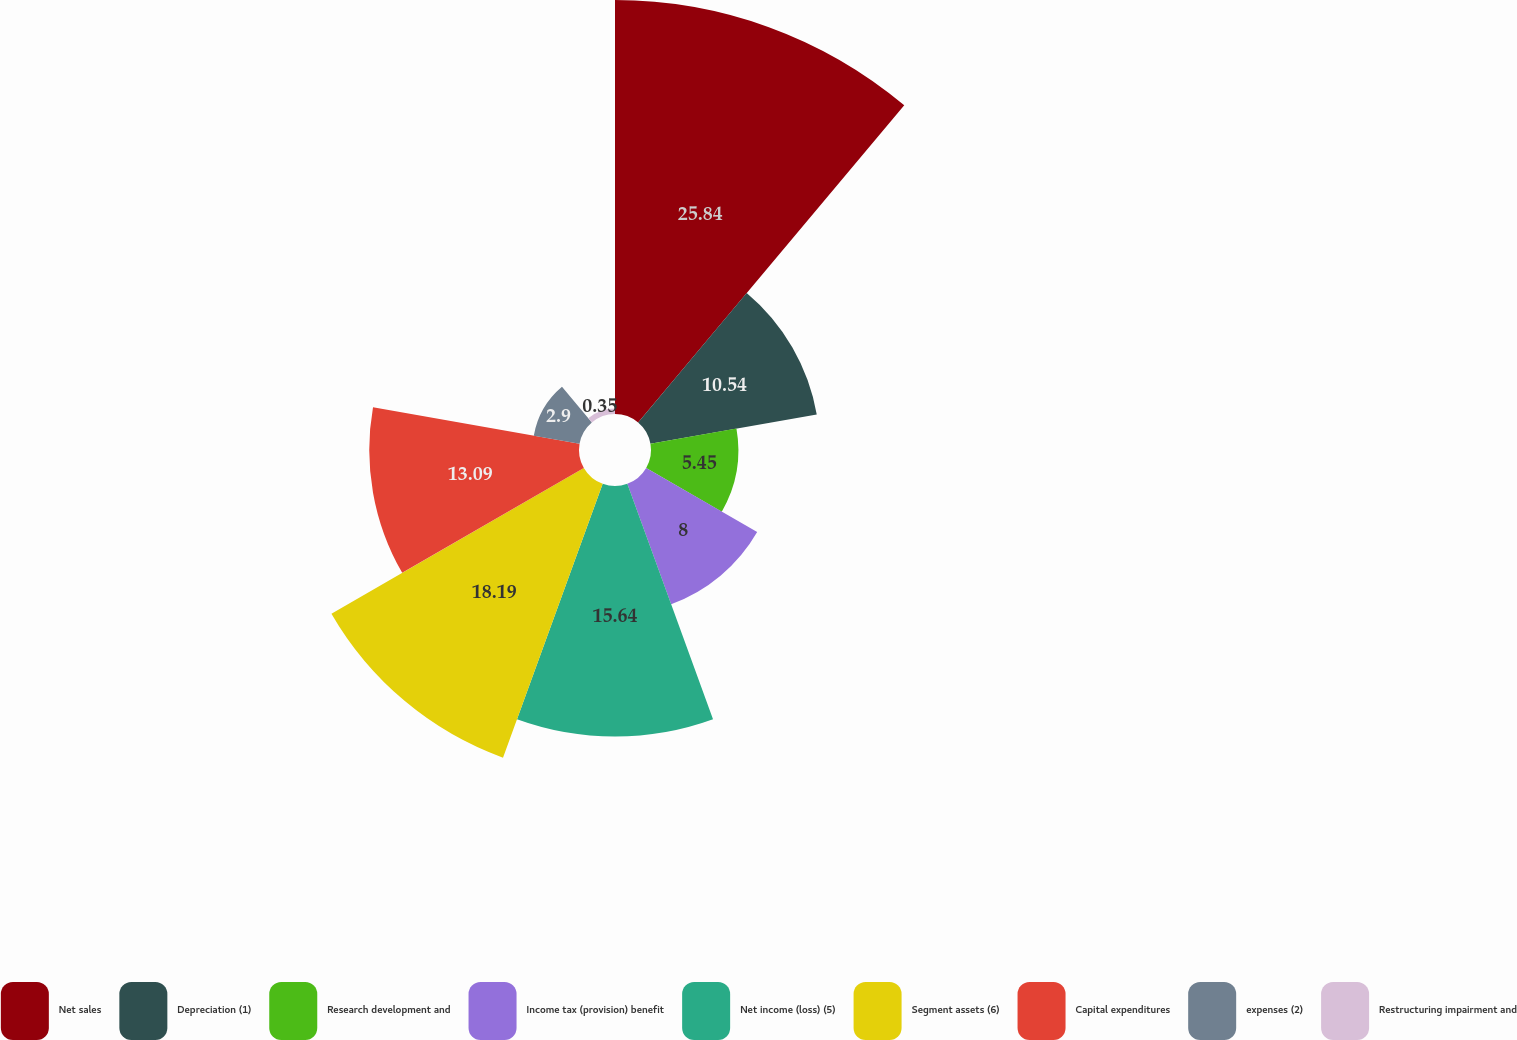<chart> <loc_0><loc_0><loc_500><loc_500><pie_chart><fcel>Net sales<fcel>Depreciation (1)<fcel>Research development and<fcel>Income tax (provision) benefit<fcel>Net income (loss) (5)<fcel>Segment assets (6)<fcel>Capital expenditures<fcel>expenses (2)<fcel>Restructuring impairment and<nl><fcel>25.84%<fcel>10.54%<fcel>5.45%<fcel>8.0%<fcel>15.64%<fcel>18.19%<fcel>13.09%<fcel>2.9%<fcel>0.35%<nl></chart> 